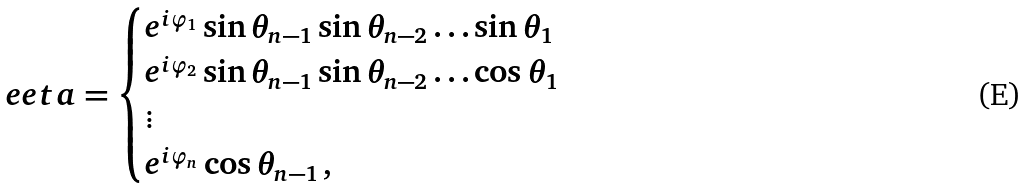<formula> <loc_0><loc_0><loc_500><loc_500>\ e e t a = \begin{cases} { e ^ { i \varphi _ { 1 } } \sin \theta _ { n - 1 } \sin \theta _ { n - 2 } \dots \sin \theta _ { 1 } } \\ e ^ { i \varphi _ { 2 } } \sin \theta _ { n - 1 } \sin \theta _ { n - 2 } \dots \cos \theta _ { 1 } \\ \vdots \\ e ^ { i \varphi _ { n } } \cos \theta _ { n - 1 } \, , \end{cases}</formula> 